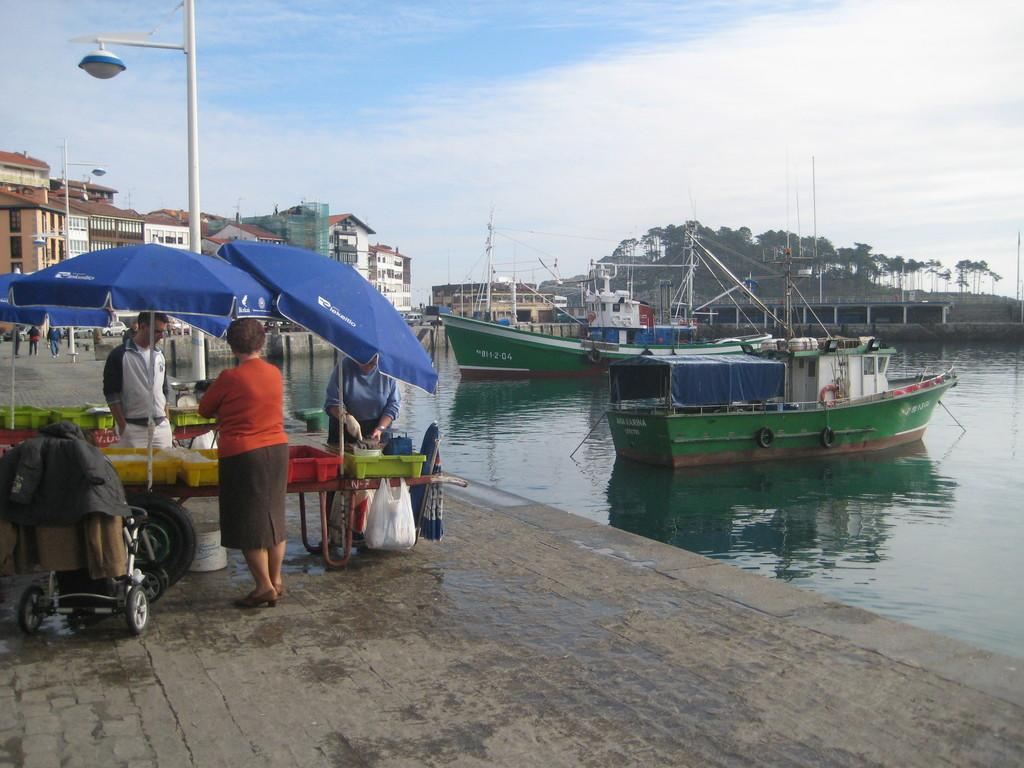What type of vehicles can be seen in the image? There are boats in the image. What is the primary setting of the image? The image features water, a building, trees, light-poles, blue tents, and a trolley, suggesting it is a waterfront or harbor area. What can be seen in the sky in the image? The sky is blue and white in color. What are the people in the image doing? There are people in the image, and one person is holding something. What type of structures are present in the image? There is a building and blue tents in the image. What type of holiday is being celebrated in the image? There is no indication of a holiday being celebrated in the image. What is the connection between the boats and the trolley in the image? There is no specific connection between the boats and the trolley mentioned in the image; they are simply different elements within the scene. Can you see any cherries in the image? There is no mention of cherries in the image, so it cannot be determined if they are present. 